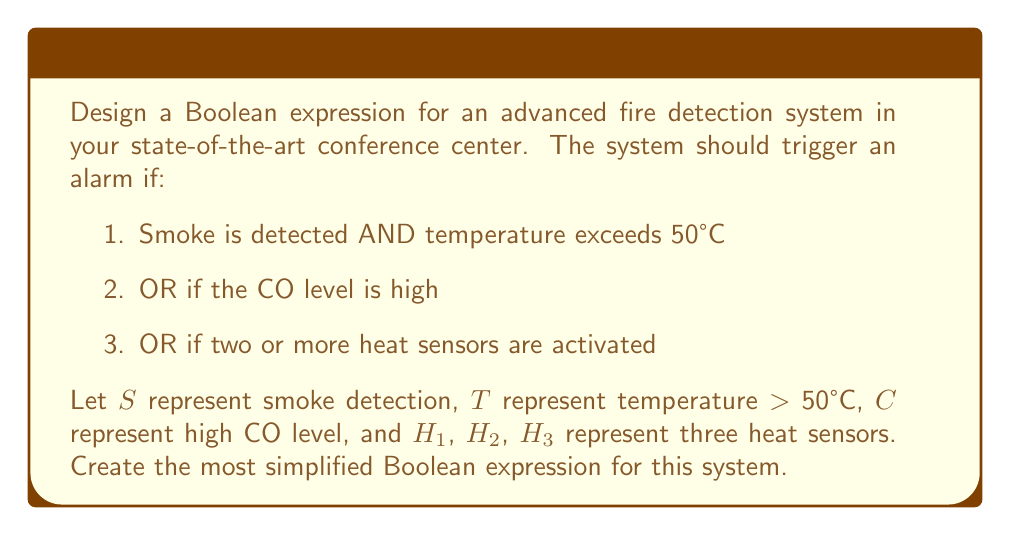Can you solve this math problem? Let's approach this step-by-step:

1. First, let's express each condition:
   - Smoke AND high temperature: $S \cdot T$
   - High CO level: $C$
   - Two or more heat sensors: We need to represent this as a combination of sensors

2. For the heat sensors, we need at least two out of three to be true. We can express this as:
   $$(H1 \cdot H2) + (H1 \cdot H3) + (H2 \cdot H3)$$

3. Now, let's combine all conditions using OR operations:
   $$(S \cdot T) + C + ((H1 \cdot H2) + (H1 \cdot H3) + (H2 \cdot H3))$$

4. This expression can be simplified using the distributive property:
   $$(S \cdot T) + C + (H1 \cdot (H2 + H3) + (H2 \cdot H3))$$

5. This is the most simplified form without losing any functionality of the system. Each term represents a condition that would trigger the alarm:
   - $(S \cdot T)$: Smoke and high temperature
   - $C$: High CO level
   - $H1 \cdot (H2 + H3) + (H2 \cdot H3)$: At least two heat sensors activated
Answer: $$(S \cdot T) + C + (H1 \cdot (H2 + H3) + (H2 \cdot H3))$$ 